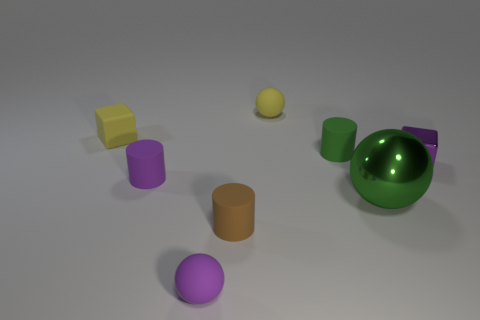Subtract all rubber balls. How many balls are left? 1 Add 1 tiny shiny balls. How many objects exist? 9 Subtract 1 cylinders. How many cylinders are left? 2 Subtract all yellow cubes. How many cubes are left? 1 Subtract all spheres. How many objects are left? 5 Subtract all purple balls. Subtract all brown cylinders. How many balls are left? 2 Subtract all yellow blocks. How many yellow spheres are left? 1 Subtract all tiny shiny things. Subtract all purple blocks. How many objects are left? 6 Add 1 purple metal things. How many purple metal things are left? 2 Add 3 purple cylinders. How many purple cylinders exist? 4 